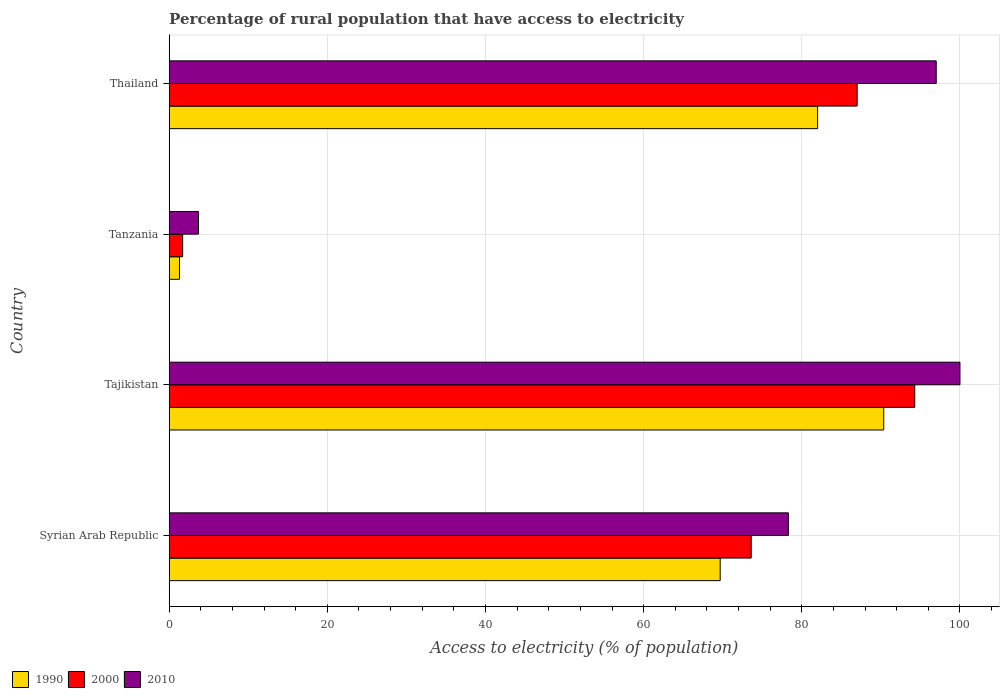How many different coloured bars are there?
Your answer should be very brief. 3. Are the number of bars per tick equal to the number of legend labels?
Give a very brief answer. Yes. How many bars are there on the 1st tick from the top?
Provide a succinct answer. 3. What is the label of the 2nd group of bars from the top?
Provide a succinct answer. Tanzania. In how many cases, is the number of bars for a given country not equal to the number of legend labels?
Offer a terse response. 0. Across all countries, what is the maximum percentage of rural population that have access to electricity in 2010?
Give a very brief answer. 100. Across all countries, what is the minimum percentage of rural population that have access to electricity in 2010?
Offer a very short reply. 3.7. In which country was the percentage of rural population that have access to electricity in 1990 maximum?
Keep it short and to the point. Tajikistan. In which country was the percentage of rural population that have access to electricity in 2000 minimum?
Keep it short and to the point. Tanzania. What is the total percentage of rural population that have access to electricity in 2000 in the graph?
Offer a terse response. 256.58. What is the difference between the percentage of rural population that have access to electricity in 2010 in Syrian Arab Republic and that in Tajikistan?
Offer a very short reply. -21.7. What is the difference between the percentage of rural population that have access to electricity in 2000 in Syrian Arab Republic and the percentage of rural population that have access to electricity in 2010 in Tanzania?
Provide a succinct answer. 69.9. What is the average percentage of rural population that have access to electricity in 2010 per country?
Offer a very short reply. 69.75. What is the difference between the percentage of rural population that have access to electricity in 2000 and percentage of rural population that have access to electricity in 1990 in Syrian Arab Republic?
Make the answer very short. 3.92. In how many countries, is the percentage of rural population that have access to electricity in 1990 greater than 80 %?
Ensure brevity in your answer.  2. What is the ratio of the percentage of rural population that have access to electricity in 2000 in Syrian Arab Republic to that in Tajikistan?
Give a very brief answer. 0.78. Is the percentage of rural population that have access to electricity in 2010 in Tajikistan less than that in Thailand?
Give a very brief answer. No. Is the difference between the percentage of rural population that have access to electricity in 2000 in Tanzania and Thailand greater than the difference between the percentage of rural population that have access to electricity in 1990 in Tanzania and Thailand?
Your answer should be very brief. No. What is the difference between the highest and the second highest percentage of rural population that have access to electricity in 1990?
Keep it short and to the point. 8.36. What is the difference between the highest and the lowest percentage of rural population that have access to electricity in 2000?
Your response must be concise. 92.58. In how many countries, is the percentage of rural population that have access to electricity in 1990 greater than the average percentage of rural population that have access to electricity in 1990 taken over all countries?
Ensure brevity in your answer.  3. Is the sum of the percentage of rural population that have access to electricity in 2010 in Syrian Arab Republic and Thailand greater than the maximum percentage of rural population that have access to electricity in 2000 across all countries?
Keep it short and to the point. Yes. What does the 1st bar from the top in Syrian Arab Republic represents?
Your response must be concise. 2010. What does the 3rd bar from the bottom in Tanzania represents?
Ensure brevity in your answer.  2010. What is the difference between two consecutive major ticks on the X-axis?
Provide a succinct answer. 20. Are the values on the major ticks of X-axis written in scientific E-notation?
Make the answer very short. No. Does the graph contain grids?
Give a very brief answer. Yes. Where does the legend appear in the graph?
Provide a succinct answer. Bottom left. What is the title of the graph?
Ensure brevity in your answer.  Percentage of rural population that have access to electricity. What is the label or title of the X-axis?
Offer a very short reply. Access to electricity (% of population). What is the label or title of the Y-axis?
Give a very brief answer. Country. What is the Access to electricity (% of population) in 1990 in Syrian Arab Republic?
Your answer should be very brief. 69.68. What is the Access to electricity (% of population) of 2000 in Syrian Arab Republic?
Offer a very short reply. 73.6. What is the Access to electricity (% of population) of 2010 in Syrian Arab Republic?
Provide a succinct answer. 78.3. What is the Access to electricity (% of population) in 1990 in Tajikistan?
Your answer should be compact. 90.36. What is the Access to electricity (% of population) in 2000 in Tajikistan?
Your response must be concise. 94.28. What is the Access to electricity (% of population) in 1990 in Tanzania?
Make the answer very short. 1.3. What is the Access to electricity (% of population) in 2000 in Tanzania?
Offer a very short reply. 1.7. What is the Access to electricity (% of population) in 2010 in Tanzania?
Your response must be concise. 3.7. What is the Access to electricity (% of population) of 1990 in Thailand?
Provide a short and direct response. 82. What is the Access to electricity (% of population) of 2010 in Thailand?
Make the answer very short. 97. Across all countries, what is the maximum Access to electricity (% of population) of 1990?
Your answer should be compact. 90.36. Across all countries, what is the maximum Access to electricity (% of population) of 2000?
Ensure brevity in your answer.  94.28. Across all countries, what is the maximum Access to electricity (% of population) in 2010?
Ensure brevity in your answer.  100. Across all countries, what is the minimum Access to electricity (% of population) in 1990?
Your response must be concise. 1.3. Across all countries, what is the minimum Access to electricity (% of population) of 2000?
Your answer should be compact. 1.7. What is the total Access to electricity (% of population) in 1990 in the graph?
Your answer should be compact. 243.34. What is the total Access to electricity (% of population) of 2000 in the graph?
Keep it short and to the point. 256.58. What is the total Access to electricity (% of population) of 2010 in the graph?
Provide a short and direct response. 279. What is the difference between the Access to electricity (% of population) in 1990 in Syrian Arab Republic and that in Tajikistan?
Give a very brief answer. -20.68. What is the difference between the Access to electricity (% of population) in 2000 in Syrian Arab Republic and that in Tajikistan?
Provide a short and direct response. -20.68. What is the difference between the Access to electricity (% of population) of 2010 in Syrian Arab Republic and that in Tajikistan?
Your answer should be compact. -21.7. What is the difference between the Access to electricity (% of population) of 1990 in Syrian Arab Republic and that in Tanzania?
Your answer should be compact. 68.38. What is the difference between the Access to electricity (% of population) of 2000 in Syrian Arab Republic and that in Tanzania?
Your response must be concise. 71.9. What is the difference between the Access to electricity (% of population) in 2010 in Syrian Arab Republic and that in Tanzania?
Make the answer very short. 74.6. What is the difference between the Access to electricity (% of population) in 1990 in Syrian Arab Republic and that in Thailand?
Offer a very short reply. -12.32. What is the difference between the Access to electricity (% of population) of 2000 in Syrian Arab Republic and that in Thailand?
Ensure brevity in your answer.  -13.4. What is the difference between the Access to electricity (% of population) of 2010 in Syrian Arab Republic and that in Thailand?
Give a very brief answer. -18.7. What is the difference between the Access to electricity (% of population) of 1990 in Tajikistan and that in Tanzania?
Your answer should be compact. 89.06. What is the difference between the Access to electricity (% of population) of 2000 in Tajikistan and that in Tanzania?
Your response must be concise. 92.58. What is the difference between the Access to electricity (% of population) in 2010 in Tajikistan and that in Tanzania?
Ensure brevity in your answer.  96.3. What is the difference between the Access to electricity (% of population) of 1990 in Tajikistan and that in Thailand?
Offer a very short reply. 8.36. What is the difference between the Access to electricity (% of population) in 2000 in Tajikistan and that in Thailand?
Give a very brief answer. 7.28. What is the difference between the Access to electricity (% of population) of 2010 in Tajikistan and that in Thailand?
Offer a very short reply. 3. What is the difference between the Access to electricity (% of population) in 1990 in Tanzania and that in Thailand?
Provide a short and direct response. -80.7. What is the difference between the Access to electricity (% of population) in 2000 in Tanzania and that in Thailand?
Your answer should be compact. -85.3. What is the difference between the Access to electricity (% of population) in 2010 in Tanzania and that in Thailand?
Your answer should be compact. -93.3. What is the difference between the Access to electricity (% of population) of 1990 in Syrian Arab Republic and the Access to electricity (% of population) of 2000 in Tajikistan?
Your answer should be very brief. -24.6. What is the difference between the Access to electricity (% of population) of 1990 in Syrian Arab Republic and the Access to electricity (% of population) of 2010 in Tajikistan?
Your answer should be compact. -30.32. What is the difference between the Access to electricity (% of population) in 2000 in Syrian Arab Republic and the Access to electricity (% of population) in 2010 in Tajikistan?
Offer a very short reply. -26.4. What is the difference between the Access to electricity (% of population) of 1990 in Syrian Arab Republic and the Access to electricity (% of population) of 2000 in Tanzania?
Your answer should be compact. 67.98. What is the difference between the Access to electricity (% of population) in 1990 in Syrian Arab Republic and the Access to electricity (% of population) in 2010 in Tanzania?
Provide a short and direct response. 65.98. What is the difference between the Access to electricity (% of population) in 2000 in Syrian Arab Republic and the Access to electricity (% of population) in 2010 in Tanzania?
Offer a terse response. 69.9. What is the difference between the Access to electricity (% of population) of 1990 in Syrian Arab Republic and the Access to electricity (% of population) of 2000 in Thailand?
Your answer should be very brief. -17.32. What is the difference between the Access to electricity (% of population) in 1990 in Syrian Arab Republic and the Access to electricity (% of population) in 2010 in Thailand?
Make the answer very short. -27.32. What is the difference between the Access to electricity (% of population) of 2000 in Syrian Arab Republic and the Access to electricity (% of population) of 2010 in Thailand?
Your response must be concise. -23.4. What is the difference between the Access to electricity (% of population) of 1990 in Tajikistan and the Access to electricity (% of population) of 2000 in Tanzania?
Your answer should be compact. 88.66. What is the difference between the Access to electricity (% of population) in 1990 in Tajikistan and the Access to electricity (% of population) in 2010 in Tanzania?
Provide a short and direct response. 86.66. What is the difference between the Access to electricity (% of population) in 2000 in Tajikistan and the Access to electricity (% of population) in 2010 in Tanzania?
Your answer should be very brief. 90.58. What is the difference between the Access to electricity (% of population) of 1990 in Tajikistan and the Access to electricity (% of population) of 2000 in Thailand?
Your answer should be very brief. 3.36. What is the difference between the Access to electricity (% of population) in 1990 in Tajikistan and the Access to electricity (% of population) in 2010 in Thailand?
Provide a short and direct response. -6.64. What is the difference between the Access to electricity (% of population) in 2000 in Tajikistan and the Access to electricity (% of population) in 2010 in Thailand?
Offer a terse response. -2.72. What is the difference between the Access to electricity (% of population) of 1990 in Tanzania and the Access to electricity (% of population) of 2000 in Thailand?
Give a very brief answer. -85.7. What is the difference between the Access to electricity (% of population) in 1990 in Tanzania and the Access to electricity (% of population) in 2010 in Thailand?
Your response must be concise. -95.7. What is the difference between the Access to electricity (% of population) of 2000 in Tanzania and the Access to electricity (% of population) of 2010 in Thailand?
Provide a short and direct response. -95.3. What is the average Access to electricity (% of population) in 1990 per country?
Make the answer very short. 60.83. What is the average Access to electricity (% of population) in 2000 per country?
Your answer should be very brief. 64.15. What is the average Access to electricity (% of population) of 2010 per country?
Give a very brief answer. 69.75. What is the difference between the Access to electricity (% of population) of 1990 and Access to electricity (% of population) of 2000 in Syrian Arab Republic?
Ensure brevity in your answer.  -3.92. What is the difference between the Access to electricity (% of population) of 1990 and Access to electricity (% of population) of 2010 in Syrian Arab Republic?
Your response must be concise. -8.62. What is the difference between the Access to electricity (% of population) in 1990 and Access to electricity (% of population) in 2000 in Tajikistan?
Give a very brief answer. -3.92. What is the difference between the Access to electricity (% of population) of 1990 and Access to electricity (% of population) of 2010 in Tajikistan?
Ensure brevity in your answer.  -9.64. What is the difference between the Access to electricity (% of population) in 2000 and Access to electricity (% of population) in 2010 in Tajikistan?
Give a very brief answer. -5.72. What is the difference between the Access to electricity (% of population) in 1990 and Access to electricity (% of population) in 2000 in Thailand?
Offer a very short reply. -5. What is the ratio of the Access to electricity (% of population) in 1990 in Syrian Arab Republic to that in Tajikistan?
Provide a short and direct response. 0.77. What is the ratio of the Access to electricity (% of population) of 2000 in Syrian Arab Republic to that in Tajikistan?
Offer a terse response. 0.78. What is the ratio of the Access to electricity (% of population) in 2010 in Syrian Arab Republic to that in Tajikistan?
Make the answer very short. 0.78. What is the ratio of the Access to electricity (% of population) in 1990 in Syrian Arab Republic to that in Tanzania?
Provide a short and direct response. 53.6. What is the ratio of the Access to electricity (% of population) of 2000 in Syrian Arab Republic to that in Tanzania?
Your answer should be very brief. 43.29. What is the ratio of the Access to electricity (% of population) in 2010 in Syrian Arab Republic to that in Tanzania?
Ensure brevity in your answer.  21.16. What is the ratio of the Access to electricity (% of population) of 1990 in Syrian Arab Republic to that in Thailand?
Ensure brevity in your answer.  0.85. What is the ratio of the Access to electricity (% of population) of 2000 in Syrian Arab Republic to that in Thailand?
Provide a short and direct response. 0.85. What is the ratio of the Access to electricity (% of population) in 2010 in Syrian Arab Republic to that in Thailand?
Your answer should be very brief. 0.81. What is the ratio of the Access to electricity (% of population) of 1990 in Tajikistan to that in Tanzania?
Offer a terse response. 69.51. What is the ratio of the Access to electricity (% of population) of 2000 in Tajikistan to that in Tanzania?
Your answer should be compact. 55.46. What is the ratio of the Access to electricity (% of population) of 2010 in Tajikistan to that in Tanzania?
Provide a succinct answer. 27.03. What is the ratio of the Access to electricity (% of population) in 1990 in Tajikistan to that in Thailand?
Provide a short and direct response. 1.1. What is the ratio of the Access to electricity (% of population) of 2000 in Tajikistan to that in Thailand?
Offer a very short reply. 1.08. What is the ratio of the Access to electricity (% of population) of 2010 in Tajikistan to that in Thailand?
Ensure brevity in your answer.  1.03. What is the ratio of the Access to electricity (% of population) in 1990 in Tanzania to that in Thailand?
Your answer should be very brief. 0.02. What is the ratio of the Access to electricity (% of population) of 2000 in Tanzania to that in Thailand?
Your answer should be very brief. 0.02. What is the ratio of the Access to electricity (% of population) in 2010 in Tanzania to that in Thailand?
Offer a very short reply. 0.04. What is the difference between the highest and the second highest Access to electricity (% of population) in 1990?
Offer a terse response. 8.36. What is the difference between the highest and the second highest Access to electricity (% of population) in 2000?
Offer a very short reply. 7.28. What is the difference between the highest and the second highest Access to electricity (% of population) of 2010?
Your answer should be very brief. 3. What is the difference between the highest and the lowest Access to electricity (% of population) in 1990?
Your response must be concise. 89.06. What is the difference between the highest and the lowest Access to electricity (% of population) in 2000?
Provide a short and direct response. 92.58. What is the difference between the highest and the lowest Access to electricity (% of population) in 2010?
Provide a succinct answer. 96.3. 